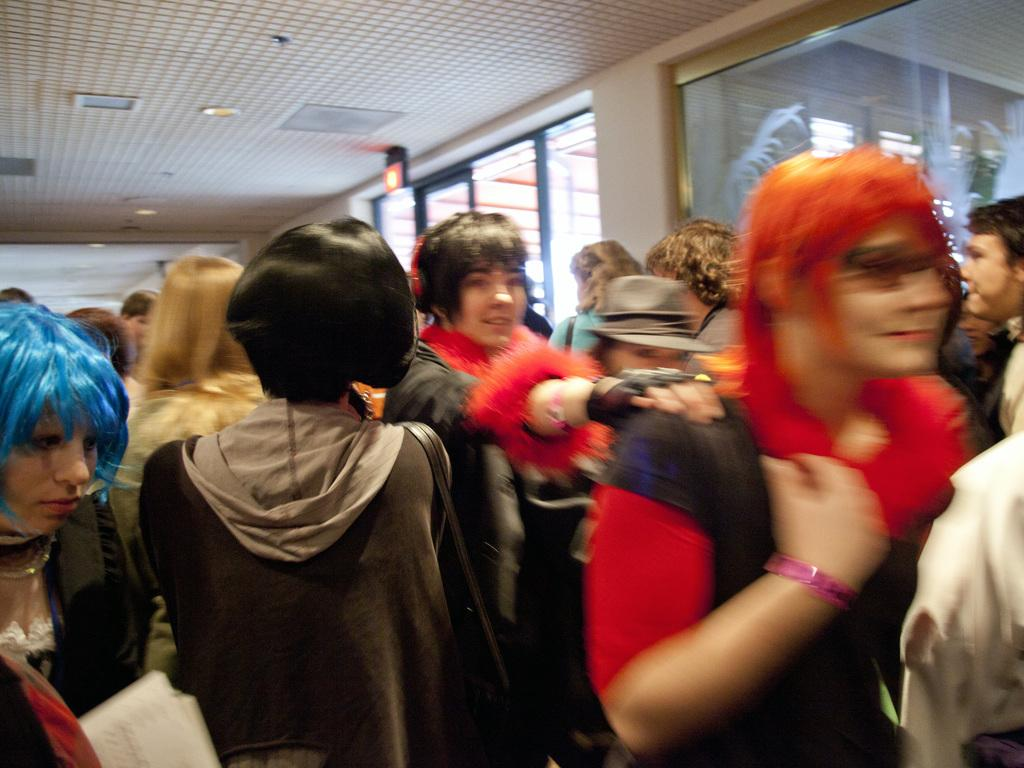What is happening in the image? There are people standing in the image. What can be seen on the left side of the image? There are glass windows on the left side of the image. What is on the roof in the image? There are lights and other objects on the roof in the image. How does the growth of the plants affect the string in the image? There are no plants or strings present in the image, so this question cannot be answered. 